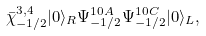Convert formula to latex. <formula><loc_0><loc_0><loc_500><loc_500>\bar { \chi } ^ { 3 , 4 } _ { - 1 / 2 } | 0 \rangle _ { R } \Psi ^ { 1 0 A } _ { - 1 / 2 } \Psi ^ { 1 0 C } _ { - 1 / 2 } | 0 \rangle _ { L } ,</formula> 